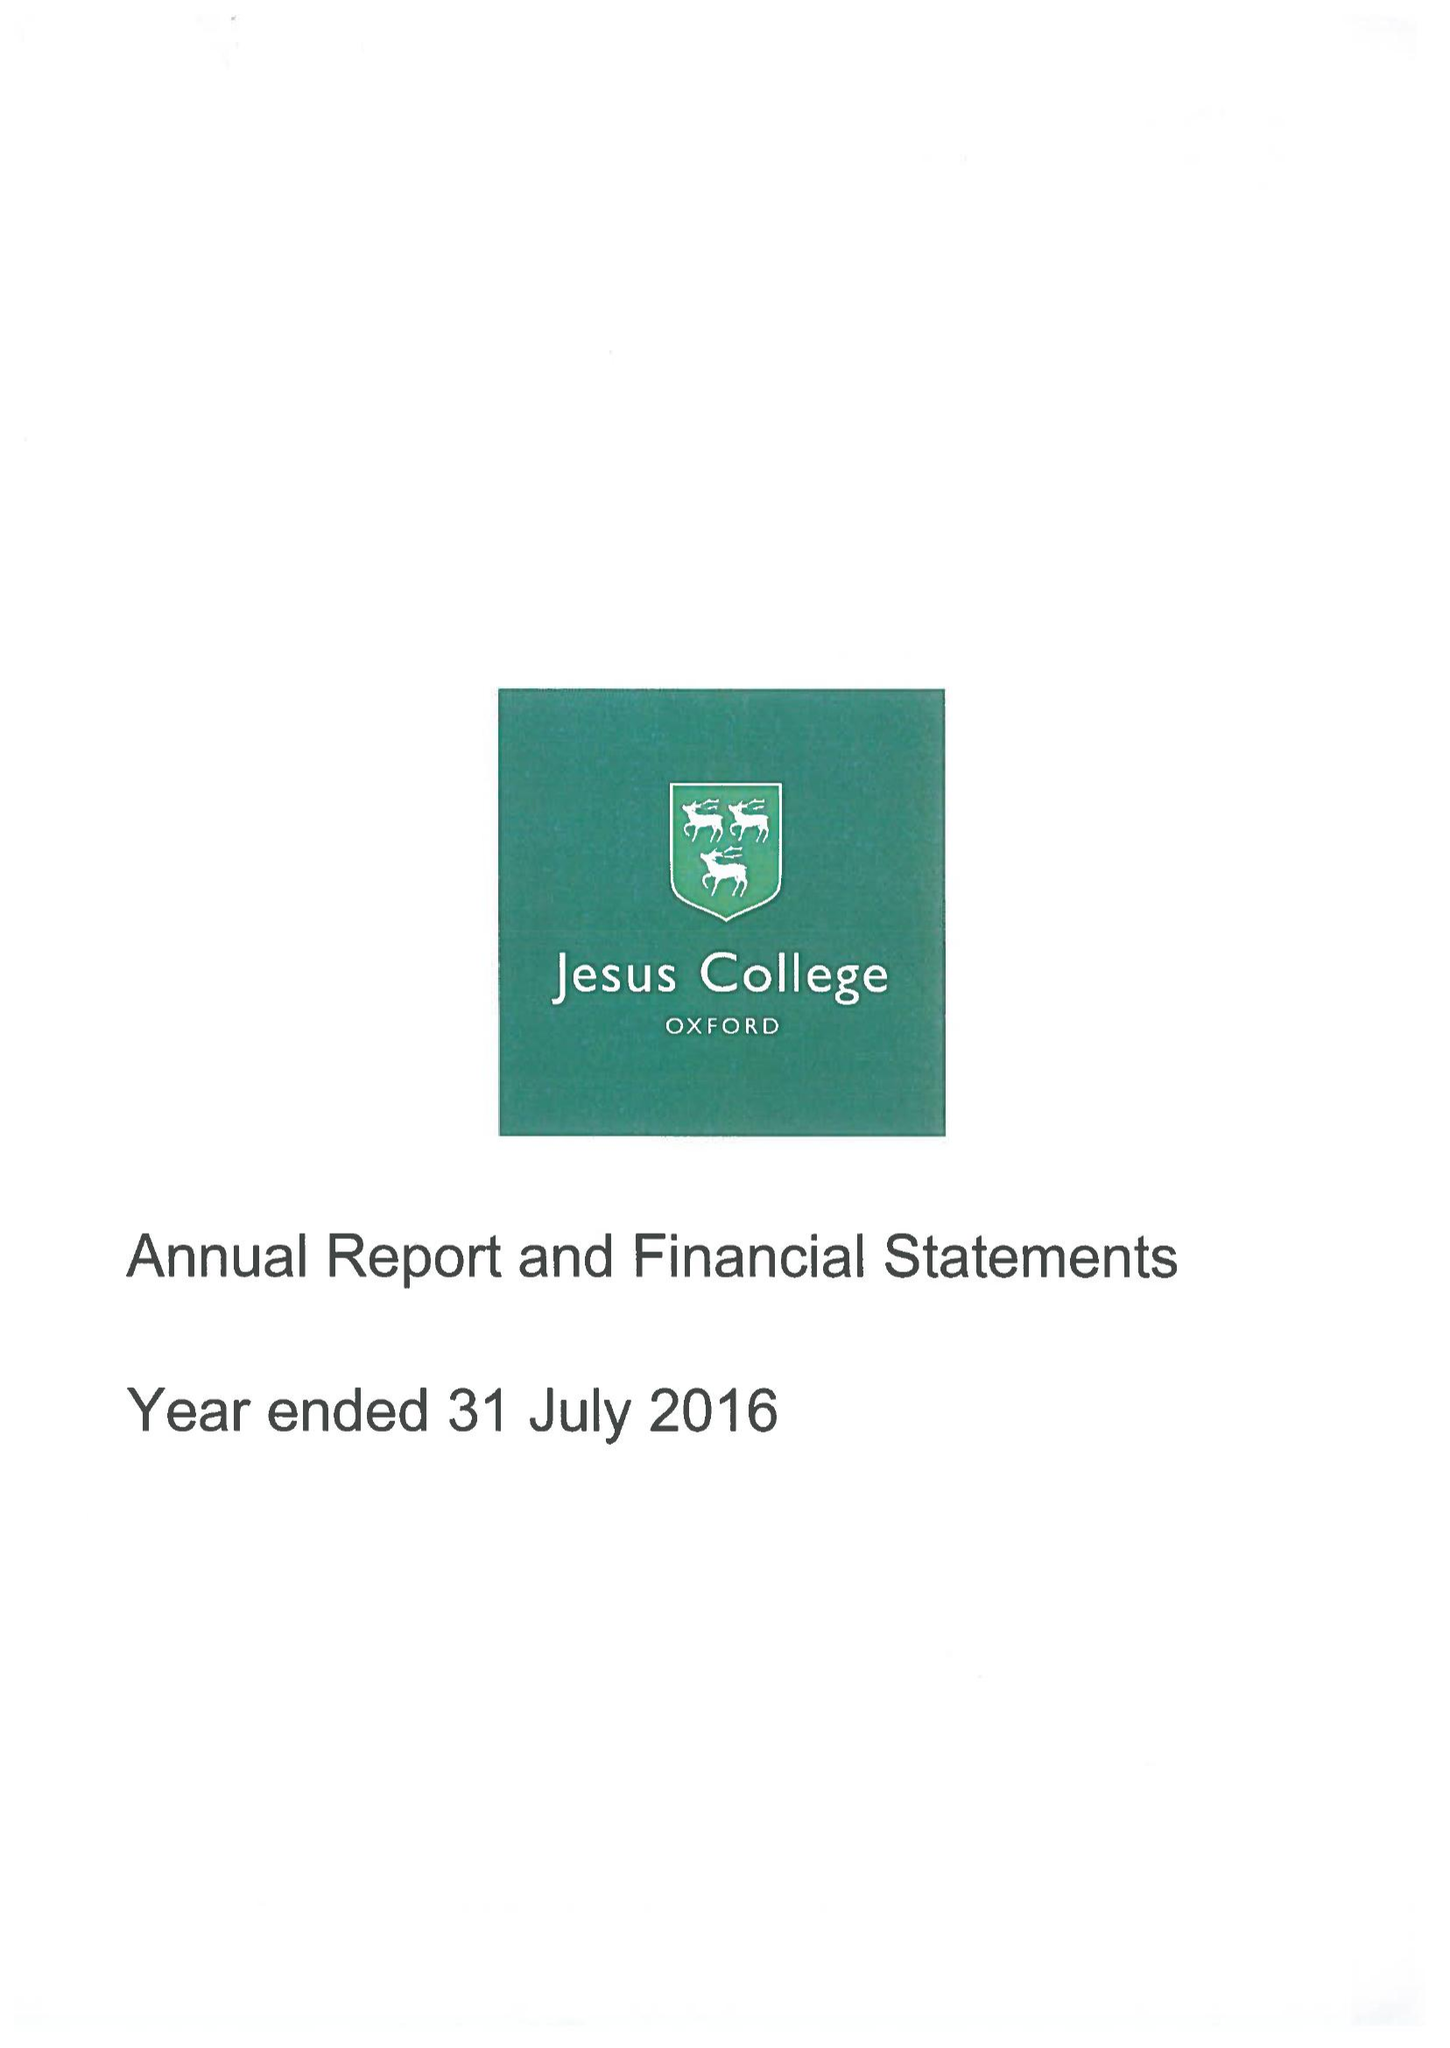What is the value for the spending_annually_in_british_pounds?
Answer the question using a single word or phrase. 11763000.00 